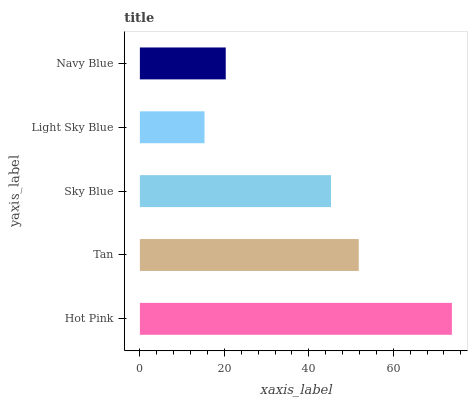Is Light Sky Blue the minimum?
Answer yes or no. Yes. Is Hot Pink the maximum?
Answer yes or no. Yes. Is Tan the minimum?
Answer yes or no. No. Is Tan the maximum?
Answer yes or no. No. Is Hot Pink greater than Tan?
Answer yes or no. Yes. Is Tan less than Hot Pink?
Answer yes or no. Yes. Is Tan greater than Hot Pink?
Answer yes or no. No. Is Hot Pink less than Tan?
Answer yes or no. No. Is Sky Blue the high median?
Answer yes or no. Yes. Is Sky Blue the low median?
Answer yes or no. Yes. Is Light Sky Blue the high median?
Answer yes or no. No. Is Light Sky Blue the low median?
Answer yes or no. No. 